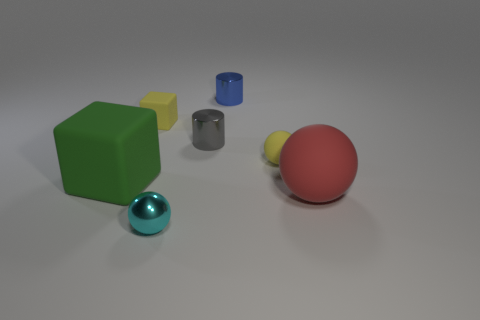Add 2 purple shiny cylinders. How many objects exist? 9 Subtract all yellow cubes. How many cubes are left? 1 Subtract all red matte spheres. How many spheres are left? 2 Subtract all blocks. How many objects are left? 5 Subtract 1 spheres. How many spheres are left? 2 Subtract all green balls. How many green cylinders are left? 0 Add 2 small matte things. How many small matte things are left? 4 Add 1 yellow matte cylinders. How many yellow matte cylinders exist? 1 Subtract 1 blue cylinders. How many objects are left? 6 Subtract all yellow cylinders. Subtract all purple balls. How many cylinders are left? 2 